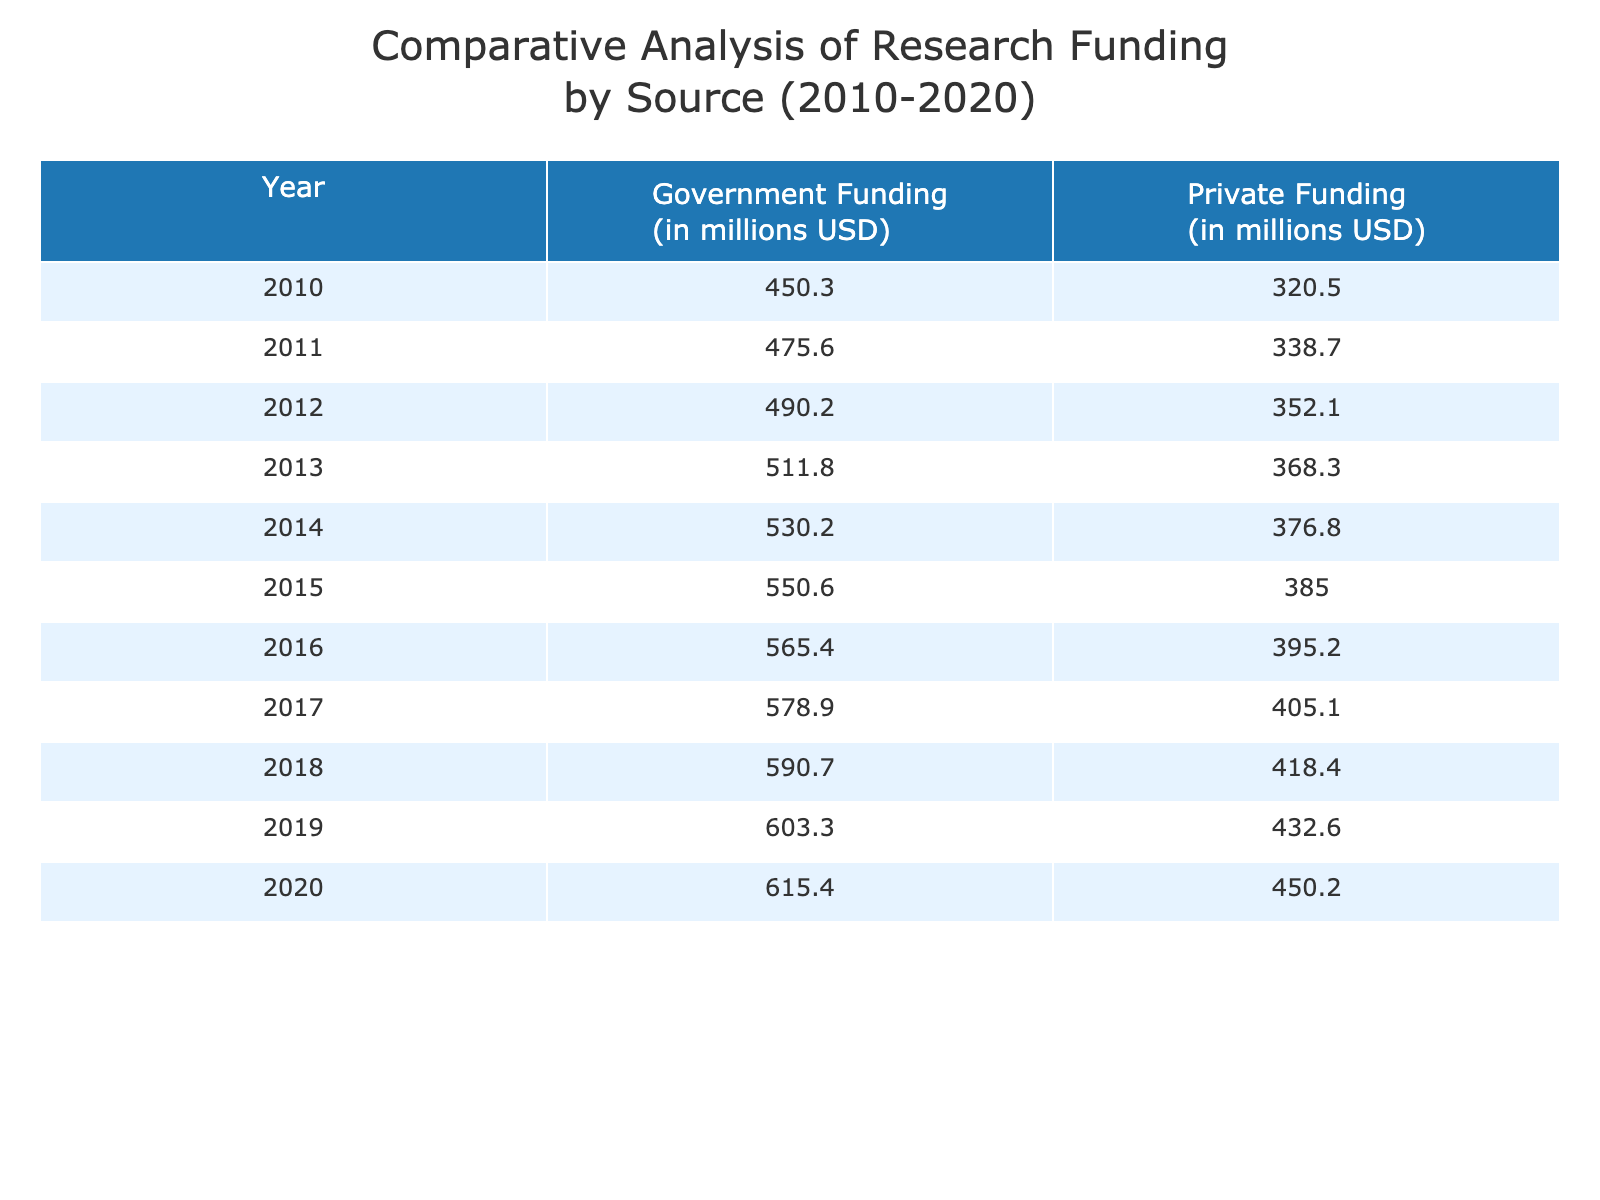What was the Government Funding in 2015? From the table, we can find the row corresponding to the year 2015. Looking at that row, the value for Government Funding is 550.6 million USD.
Answer: 550.6 million USD What is the total Private Funding from 2010 to 2020? To calculate the total Private Funding, we sum up the values in the Private Funding column: 320.5 + 338.7 + 352.1 + 368.3 + 376.8 + 385.0 + 395.2 + 405.1 + 418.4 + 432.6 = 4, 878.7 million USD.
Answer: 4,878.7 million USD Was the Private Funding higher than Government Funding in any year? By comparing the values in each row, we can see that all values for Private Funding are lower than the corresponding Government Funding values for all years from 2010 to 2020. Therefore, the answer is no.
Answer: No What was the difference in Government Funding between 2010 and 2020? We find the Government Funding for 2010 which is 450.3 million USD and for 2020 which is 615.4 million USD. The difference is 615.4 - 450.3 = 165.1 million USD.
Answer: 165.1 million USD What was the average Government Funding from 2010 to 2020? There are 11 years of data (from 2010 to 2020). Adding the Government Funding values gives: 450.3 + 475.6 + 490.2 + 511.8 + 530.2 + 550.6 + 565.4 + 578.9 + 590.7 + 603.3 + 615.4 = 6, 564.0 million USD. Dividing by 11 gives an average of 596.72 million USD.
Answer: 596.72 million USD In which year did Private Funding reach its highest value? Looking through the Private Funding column, we see that the highest value is in 2020 at 450.2 million USD. This is the last year in the table, and checking the preceding years confirms this is indeed the maximum.
Answer: 2020 